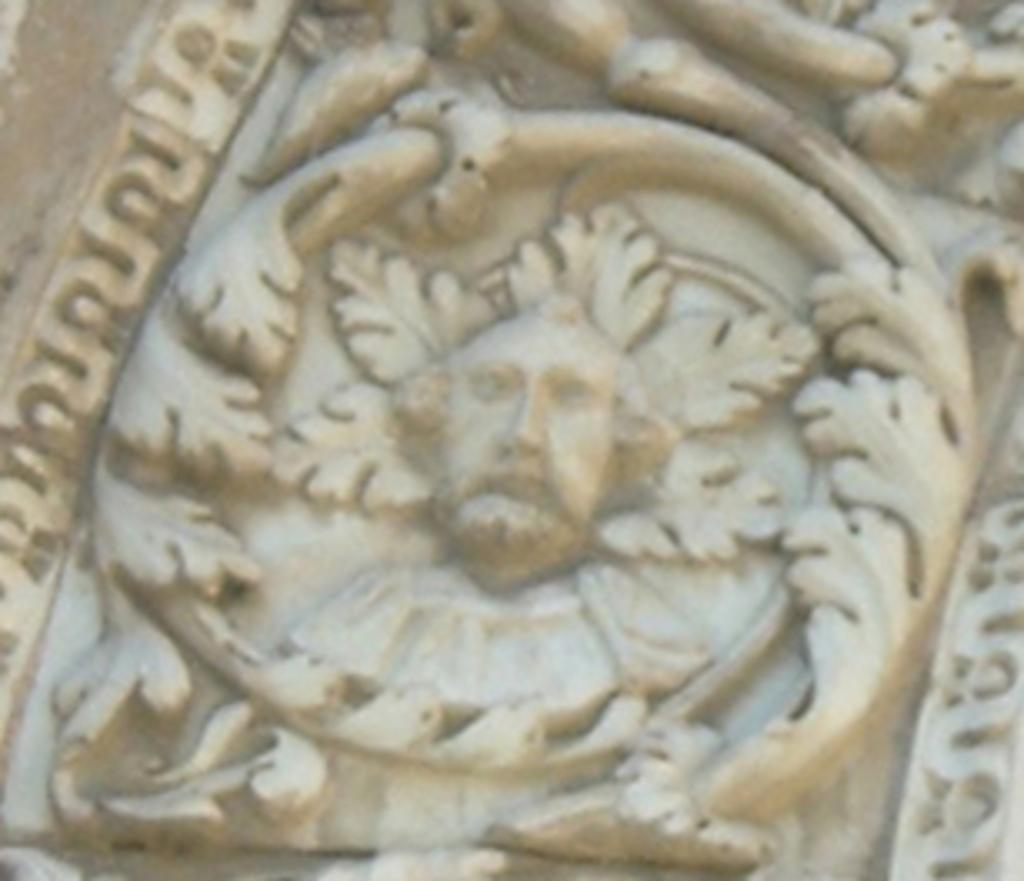Describe this image in one or two sentences. In the center of the image, we can see a sculpture. 